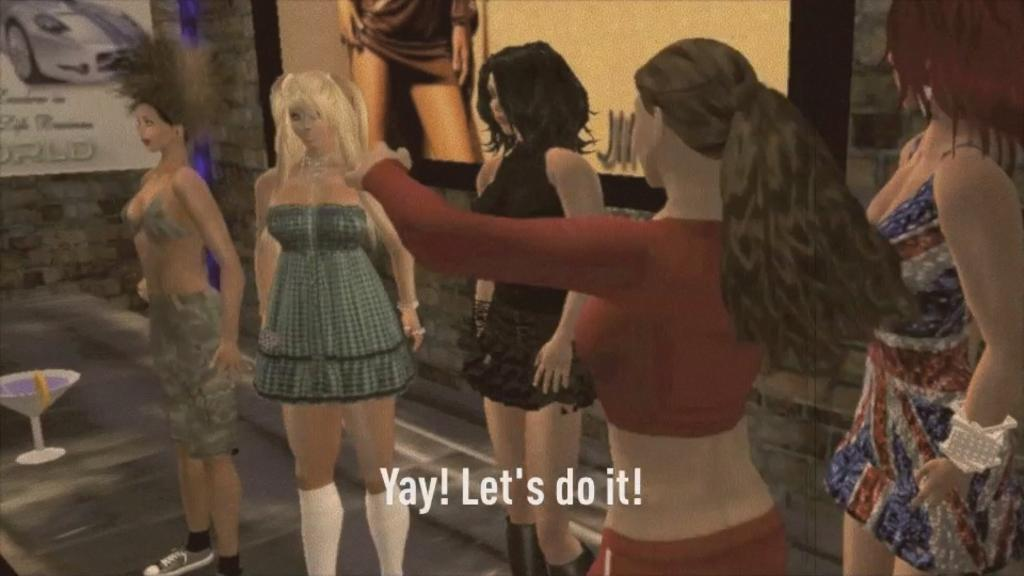Who or what can be seen in the image? There are people in the image. What else is present in the image besides the people? There is an object in the image. What can be seen in the background of the image? There is a wall and banners in the background of the image. Is there any text visible in the image? Yes, there is text written at the bottom of the image. What type of dirt can be seen on the guitar in the image? There is no guitar present in the image, so there is no dirt to be seen on it. 